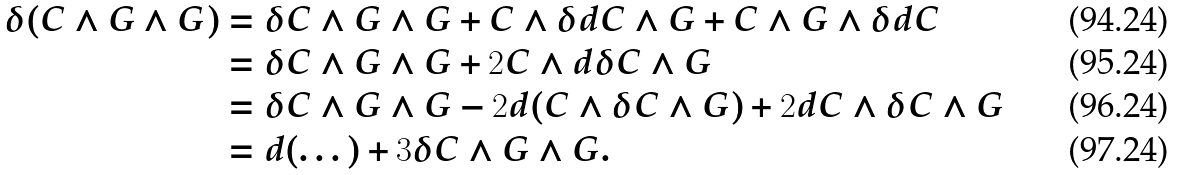<formula> <loc_0><loc_0><loc_500><loc_500>\delta ( C \wedge G \wedge G ) & = \delta C \wedge G \wedge G + C \wedge \delta d C \wedge G + C \wedge G \wedge \delta d C \\ & = \delta C \wedge G \wedge G + 2 C \wedge d \delta C \wedge G \\ & = \delta C \wedge G \wedge G - 2 d ( C \wedge \delta C \wedge G ) + 2 d C \wedge \delta C \wedge G \\ & = d ( \dots ) + 3 \delta C \wedge G \wedge G .</formula> 